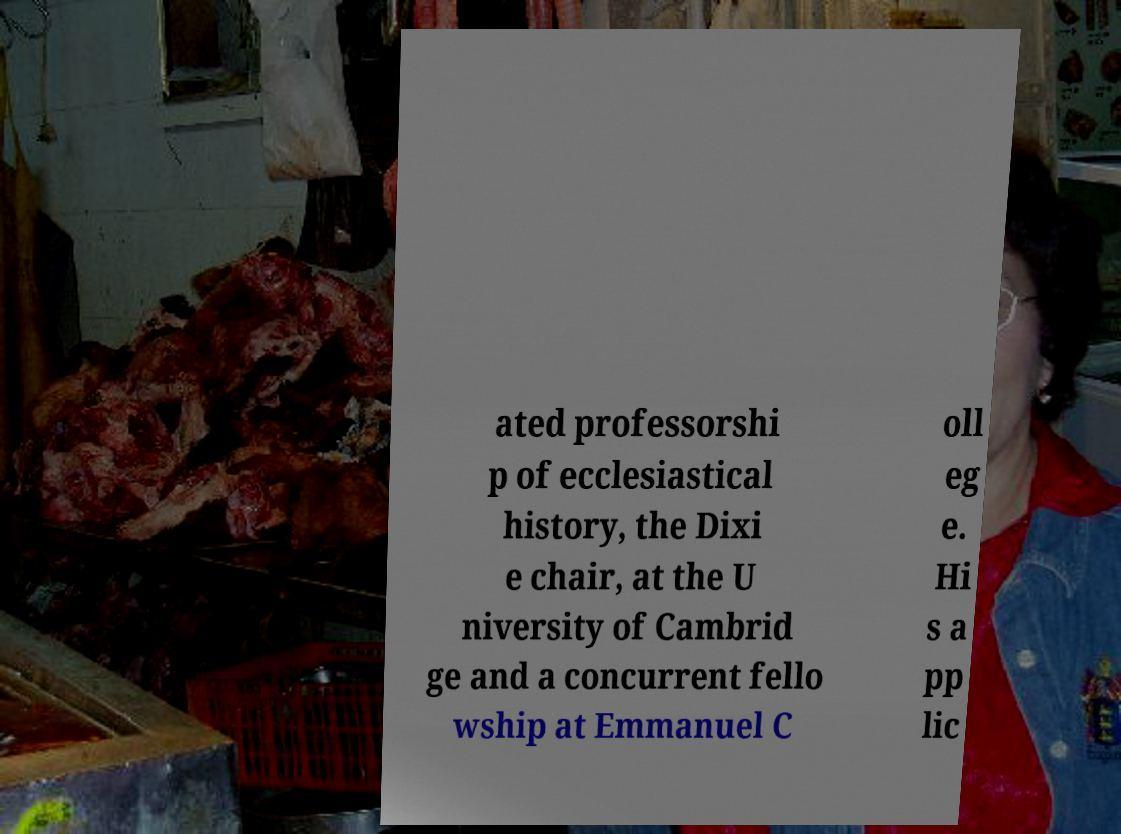I need the written content from this picture converted into text. Can you do that? ated professorshi p of ecclesiastical history, the Dixi e chair, at the U niversity of Cambrid ge and a concurrent fello wship at Emmanuel C oll eg e. Hi s a pp lic 